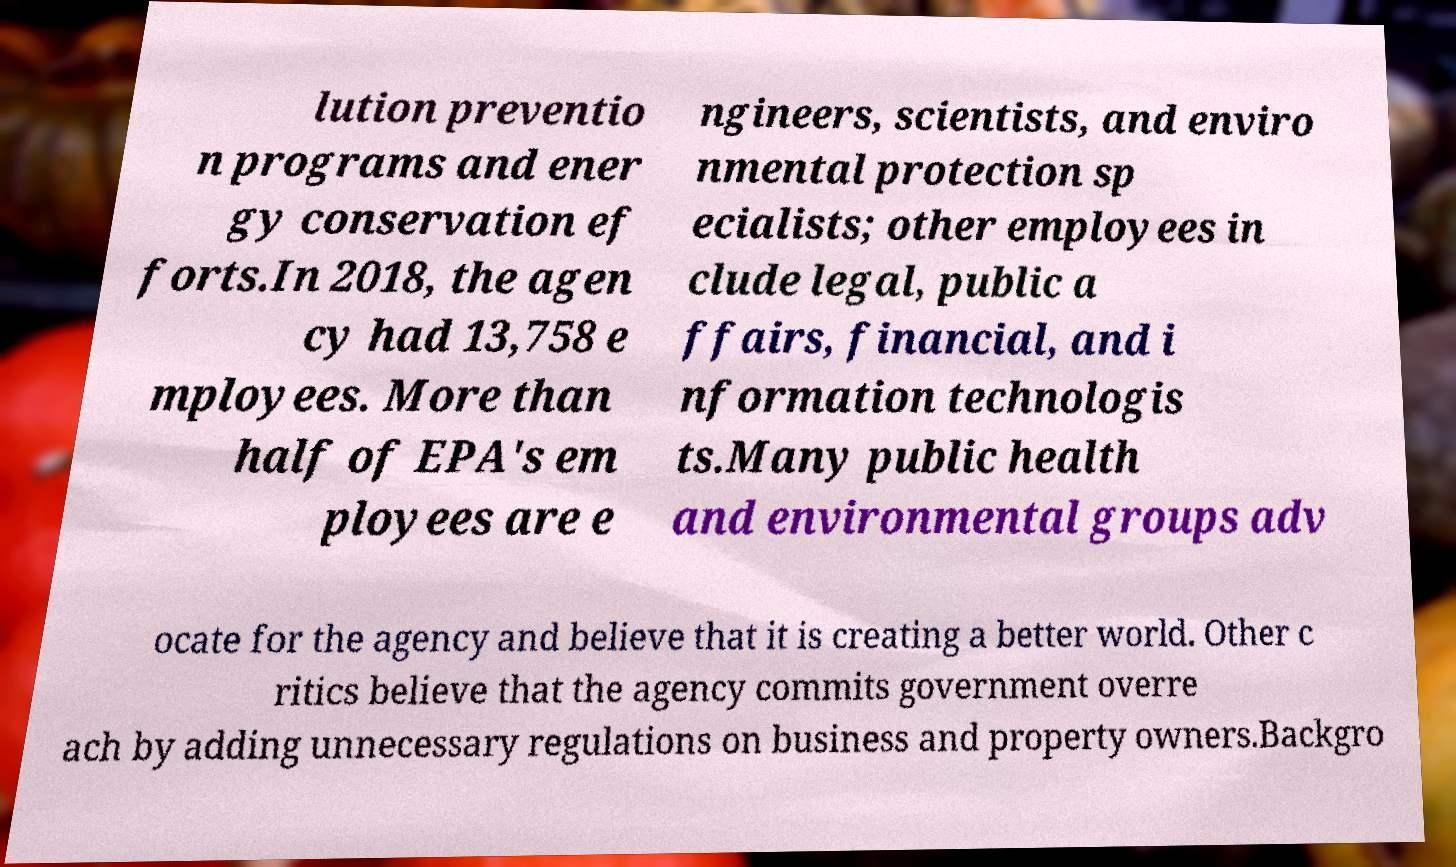There's text embedded in this image that I need extracted. Can you transcribe it verbatim? lution preventio n programs and ener gy conservation ef forts.In 2018, the agen cy had 13,758 e mployees. More than half of EPA's em ployees are e ngineers, scientists, and enviro nmental protection sp ecialists; other employees in clude legal, public a ffairs, financial, and i nformation technologis ts.Many public health and environmental groups adv ocate for the agency and believe that it is creating a better world. Other c ritics believe that the agency commits government overre ach by adding unnecessary regulations on business and property owners.Backgro 